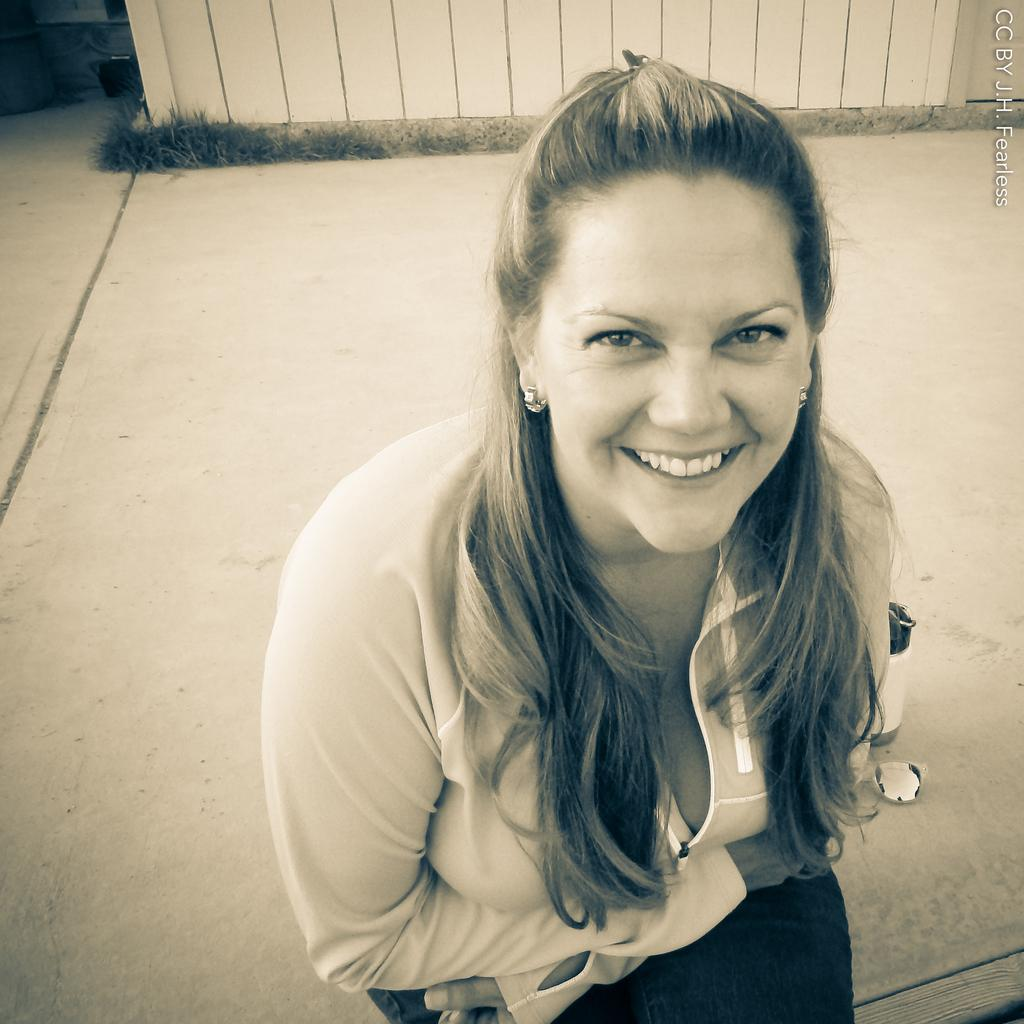What is the woman in the image doing? The woman is sitting in the image. What is the woman wearing? The woman is wearing clothes and earrings. What is the woman's facial expression? The woman is smiling. What objects can be seen in the image besides the woman? There is a bottle, a footpath, a watermark, grass, and a fence in the image. What type of music can be heard coming from the volcano in the image? There is no volcano present in the image, so it's not possible to determine what, if any, music might be heard. 